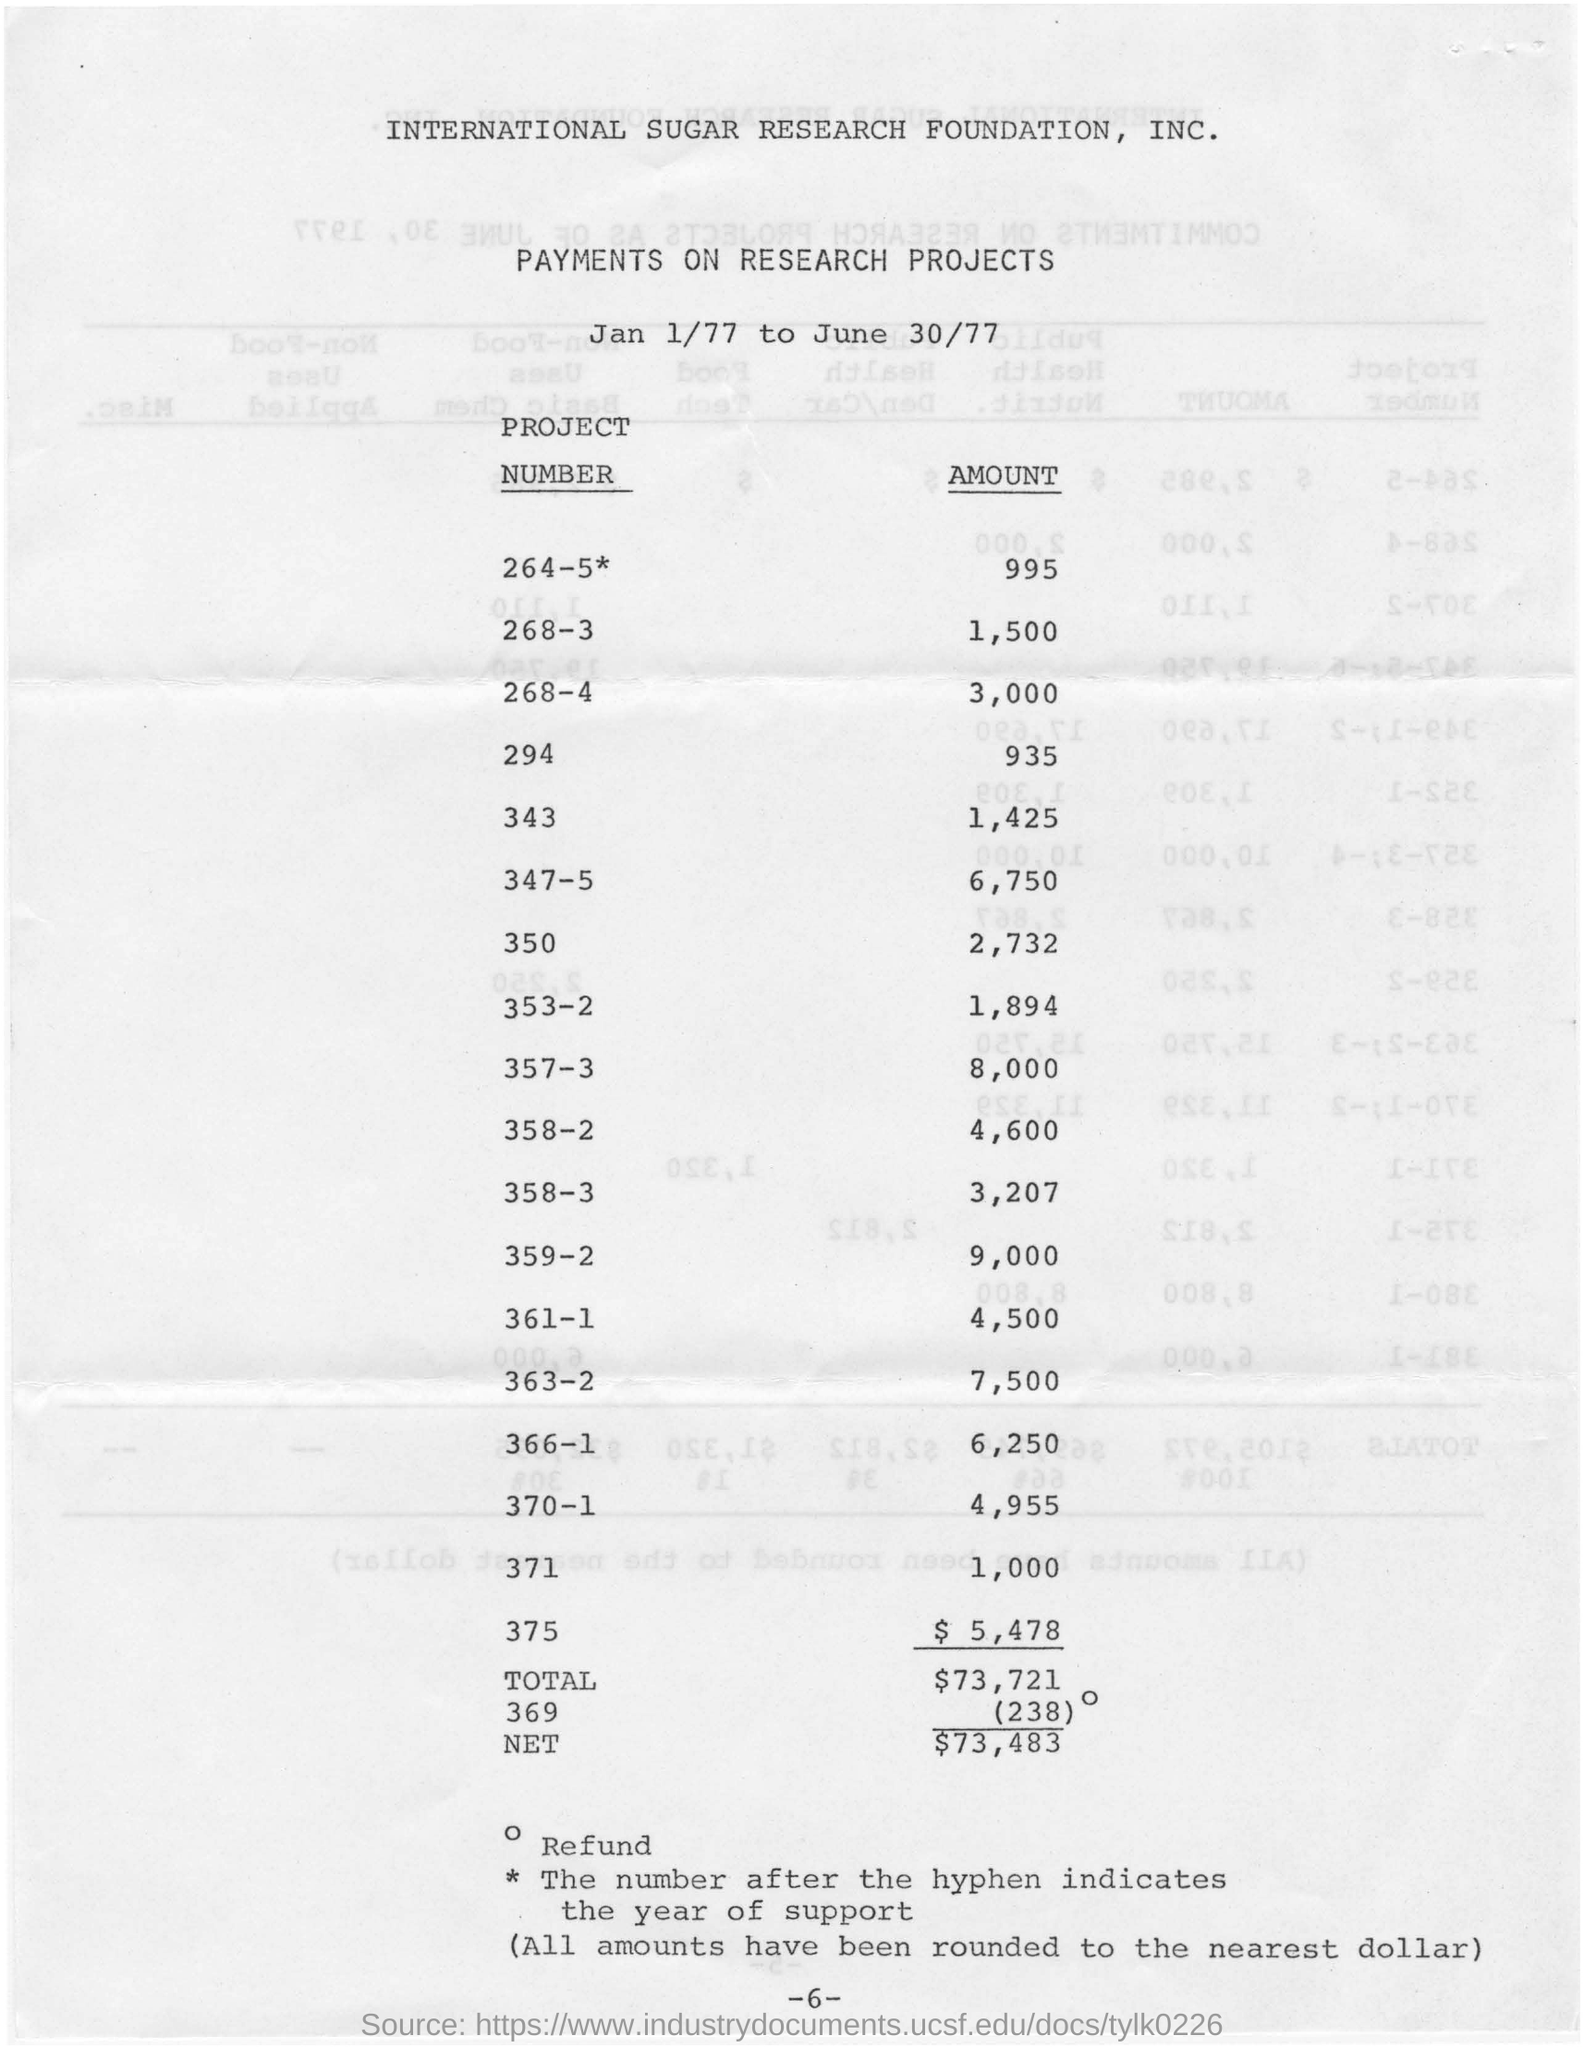What is the amount for project number 294?
Make the answer very short. 935. What is the amount for project number 350?
Make the answer very short. 2,732. What is the amount for project number 370-1?
Your answer should be compact. 4,955. 